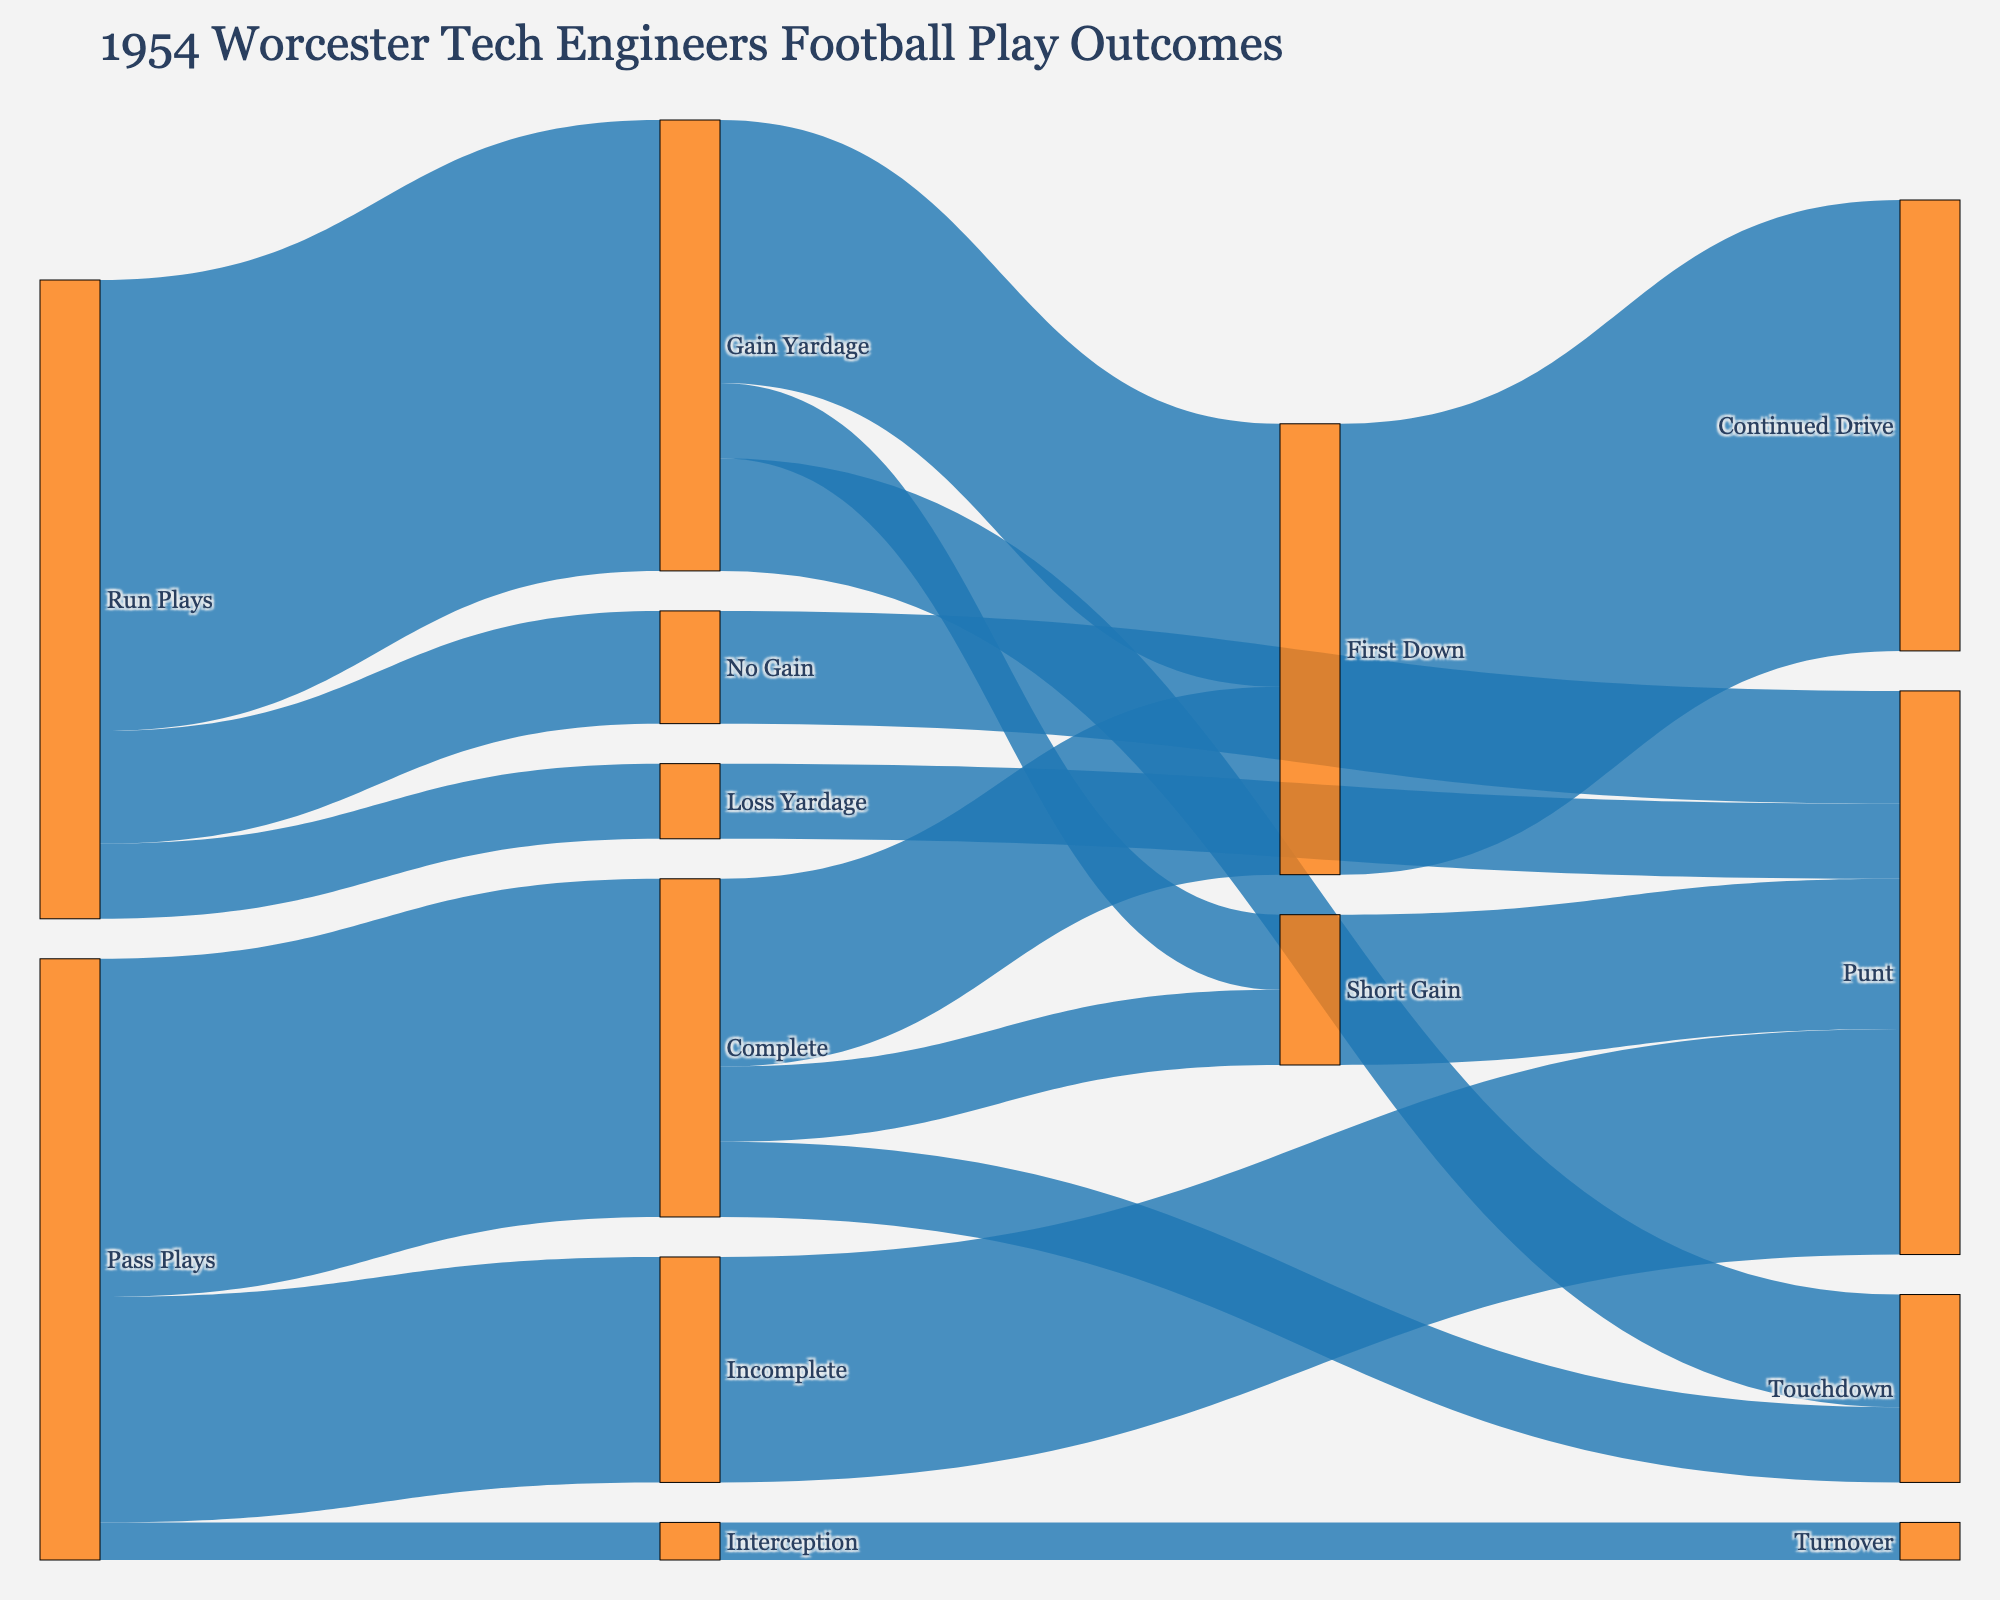What is the title of the Sankey diagram? The title of the Sankey diagram is displayed at the top and it provides an overview of what the chart represents.
Answer: 1954 Worcester Tech Engineers Football Play Outcomes What is the most frequent outcome for pass plays? To find the most frequent outcome for pass plays, look at the "Pass Plays" node and trace the connections. The connection with the highest value indicates the most frequent outcome.
Answer: Complete How many touchdowns result from run plays that gain yardage? Trace the flow from "Run Plays" to "Gain Yardage" and then to "Touchdown". The number at this connection is the answer.
Answer: 15 Which type of plays result in more first downs, pass or run plays? Compare the number of first downs resulting from "Complete" under pass plays and "Gain Yardage" under run plays. Sum the values leading to "First Down" for each type.
Answer: Run Plays What is the sum of plays that result in a punt? Add all values leading to "Punt" from "Incomplete," "Short Gain," "No Gain," and "Loss Yardage."
Answer: 75 How many total pass plays were attempted? Add the values of all pass play outcomes: "Complete," "Incomplete," and "Interception."
Answer: 80 Do incomplete pass plays result in more punts than "No Gain" run plays? Compare the value leading to "Punt" from "Incomplete" with the value leading to "Punt" from "No Gain."
Answer: Yes What is the total number of plays that result in a turnover? Look at the value leading to "Turnover" from "Interception."
Answer: 5 How many short gains were achieved through pass plays? Trace the flow from "Pass Plays" to "Complete" and then to "Short Gain."
Answer: 10 Which outcome results more in touchdowns, passes or runs? Compare the value of "Touchdown" from "Complete" (pass plays) and "Gain Yardage" (run plays).
Answer: Runs 